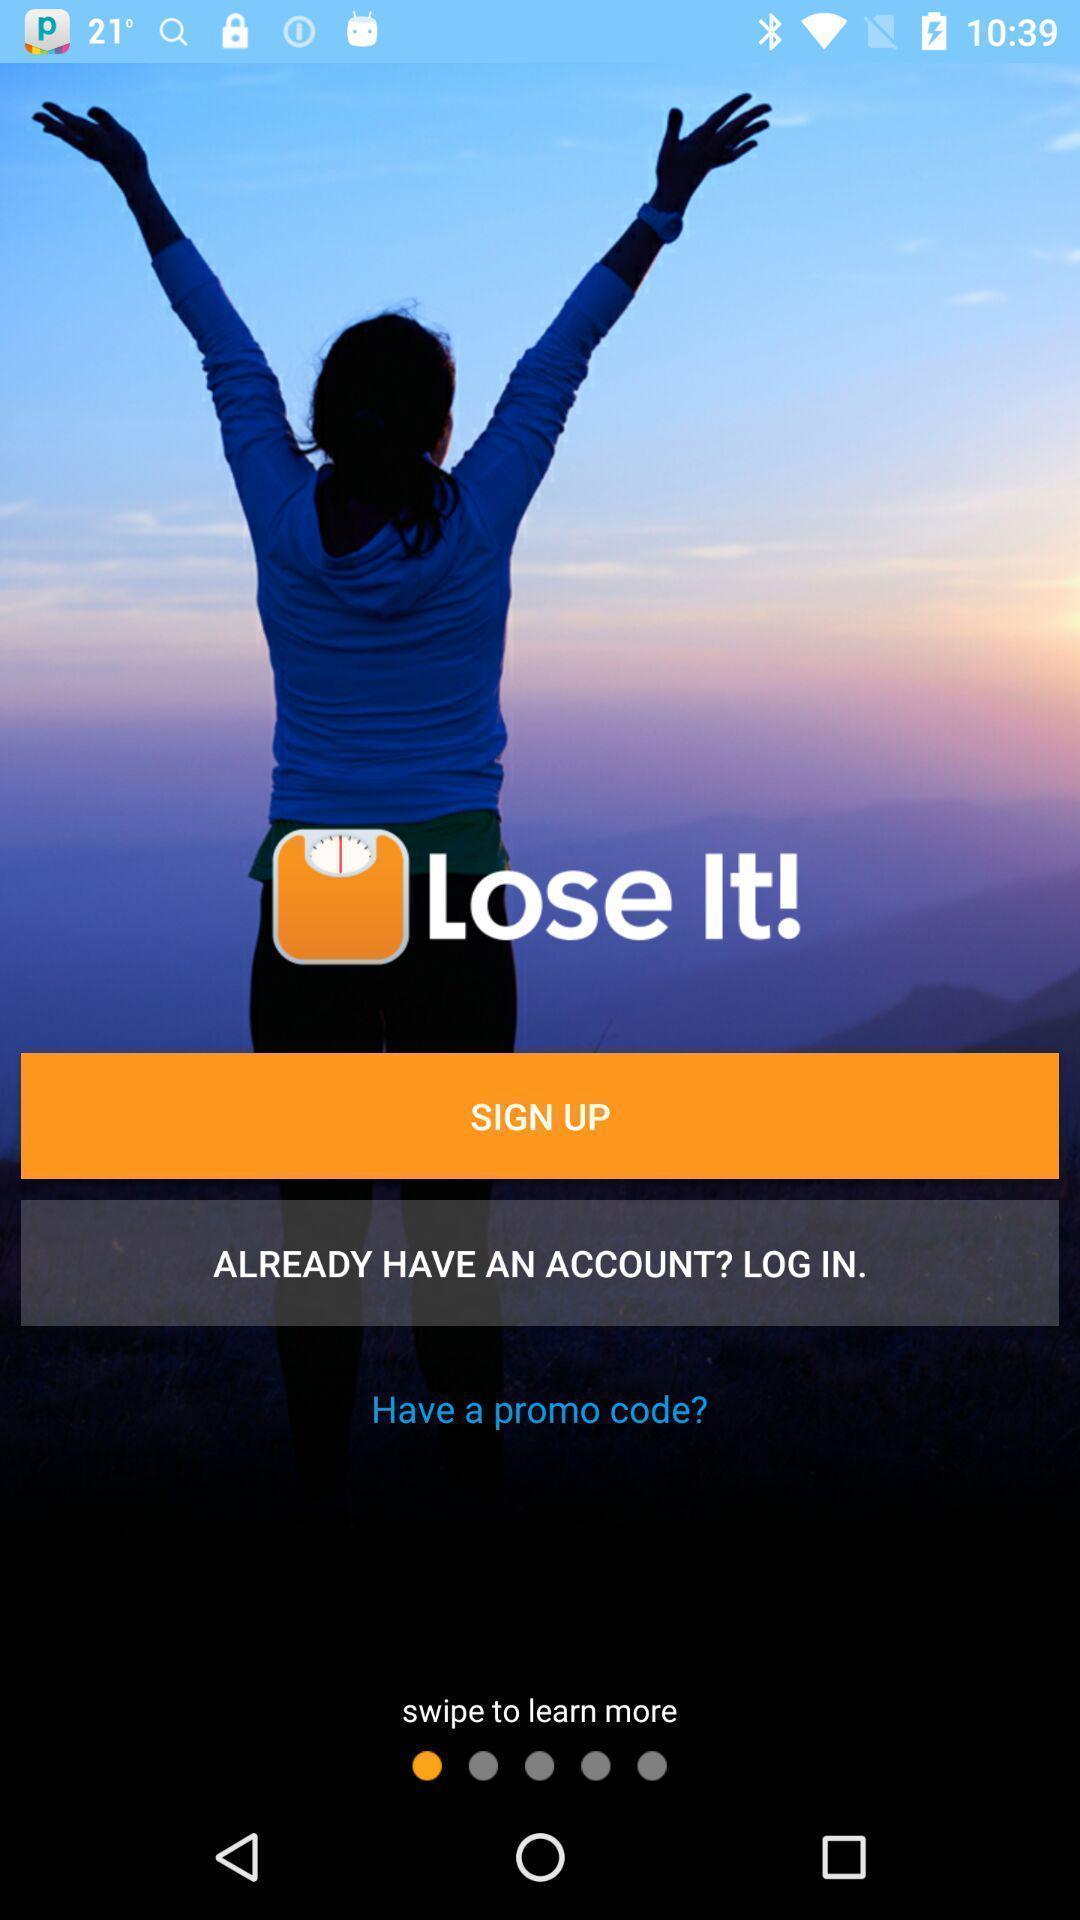Describe the visual elements of this screenshot. Welcome page displaying login options to continue with account. 